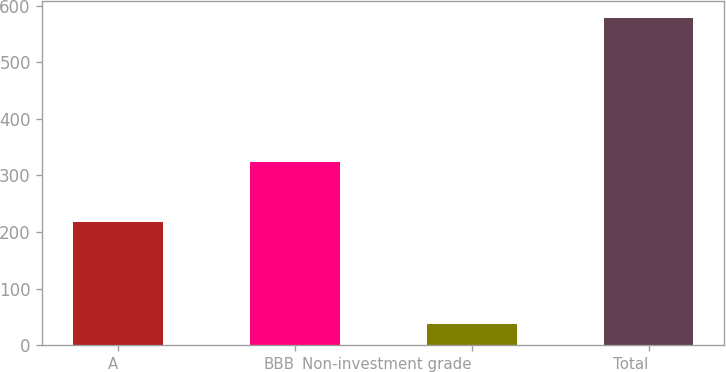<chart> <loc_0><loc_0><loc_500><loc_500><bar_chart><fcel>A<fcel>BBB<fcel>Non-investment grade<fcel>Total<nl><fcel>217<fcel>324<fcel>38<fcel>579<nl></chart> 